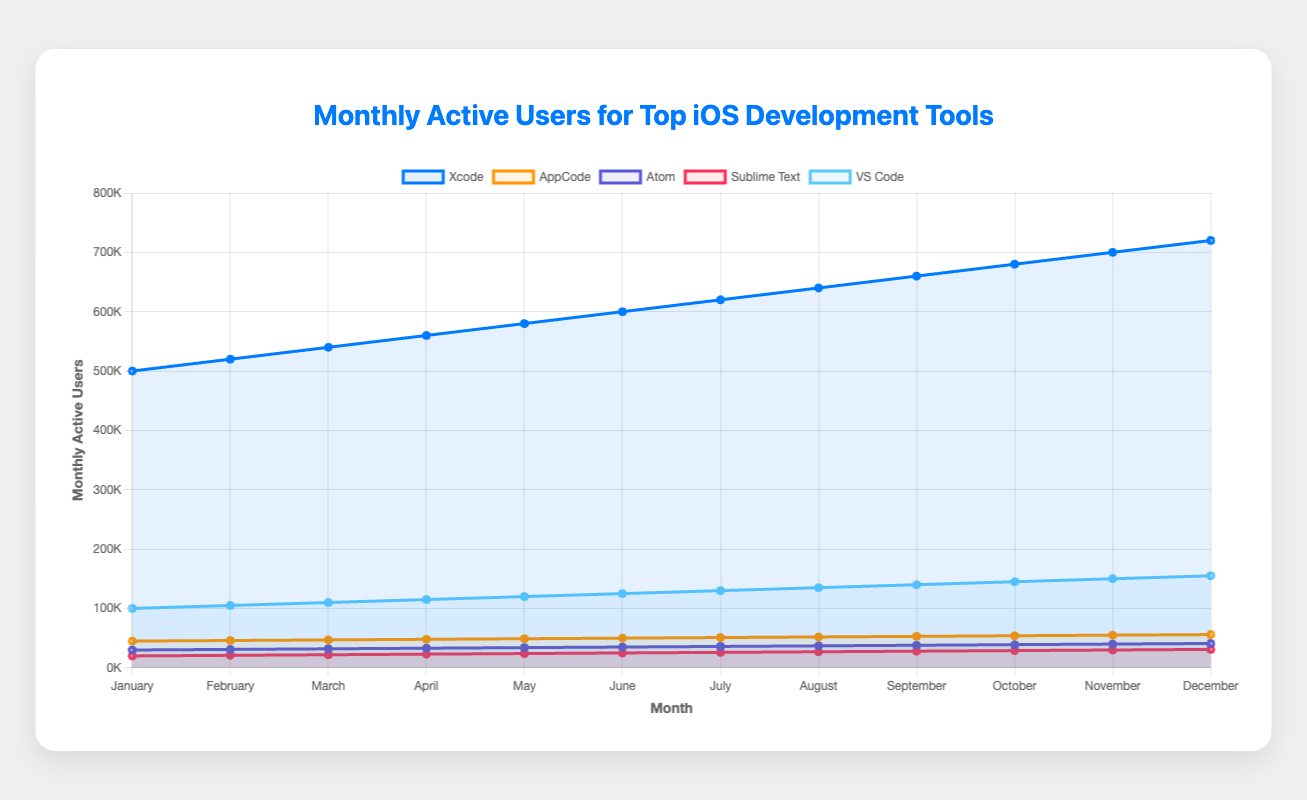What's the biggest visual difference between the lines representing Xcode and Atom? The line for Xcode almost constantly slopes upward and is significantly higher on the chart compared to Atom's line, which is much lower and also slopes upward but more gradually.
Answer: Xcode's line is much higher and more steeply sloped Which development tool has the smallest number of monthly active users in December? The chart shows that Sublime Text has the smallest number of monthly active users in December with its line being the lowest among all tools.
Answer: Sublime Text By how much did the number of active users for AppCode increase from January to December? From January's 45,000 to December's 56,000, the increase is calculated as 56,000 - 45,000.
Answer: 11,000 Is Xcode always the tool with the highest number of monthly active users throughout the year? By visually comparing the heights of the lines each month, one can see that the Xcode line is consistently the highest line on the chart.
Answer: Yes What is the average number of monthly active users for VS Code in the first quarter of the year? To find the average: (100,000 + 105,000 + 110,000) / 3, which results in the average for January, February, and March.
Answer: 105,000 Which month shows the smallest gap in active users between VS Code and Xcode? Subtracting VS Code's users from Xcode's users month-by-month shows that August has the smallest gap where Xcode has 640,000 and VS Code has 135,000, so 640,000 - 135,000.
Answer: 505,000 In which month did Atom experience the highest growth in monthly active users? By observing the steepness of Atom's line, the greatest monthly difference is between June and July, from 35,000 to 36,000 users.
Answer: July Approximately how many times more active users does Xcode have compared to Sublime Text in November? November shows Xcode at 700,000 and Sublime Text at 30,000, so 700,000 / 30,000 = ~23.3 times.
Answer: ~23.3 times If the trend continues, what would you estimate VS Code's user base to be in January of next year? Extrapolating from the consistent monthly increase of 5,000: December's 155,000 + 5,000 = 160,000.
Answer: 160,000 